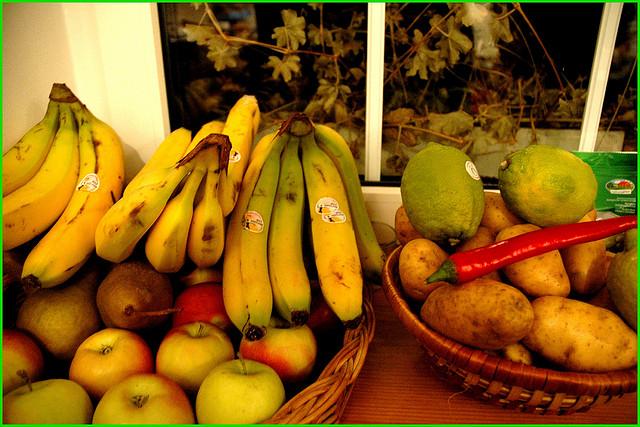How many limes are there?
Quick response, please. 2. Which side of the photograph has vegetables?
Answer briefly. Right. How many bunches of bananas are pictured?
Short answer required. 3. Do the bananas have stickers on them?
Quick response, please. Yes. 